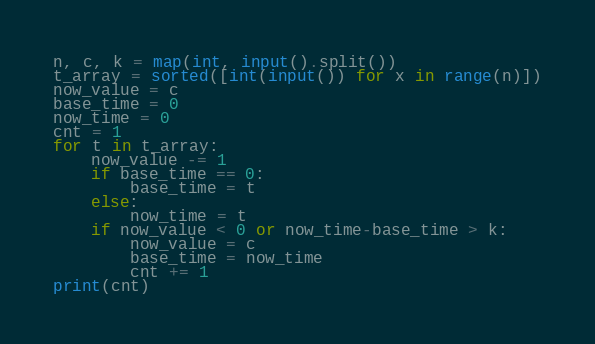Convert code to text. <code><loc_0><loc_0><loc_500><loc_500><_Python_>n, c, k = map(int, input().split())
t_array = sorted([int(input()) for x in range(n)])
now_value = c
base_time = 0
now_time = 0
cnt = 1
for t in t_array:
    now_value -= 1
    if base_time == 0:
        base_time = t
    else:
        now_time = t
    if now_value < 0 or now_time-base_time > k:
        now_value = c
        base_time = now_time
        cnt += 1
print(cnt)</code> 